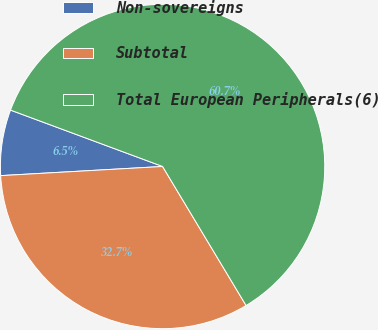Convert chart. <chart><loc_0><loc_0><loc_500><loc_500><pie_chart><fcel>Non-sovereigns<fcel>Subtotal<fcel>Total European Peripherals(6)<nl><fcel>6.55%<fcel>32.71%<fcel>60.74%<nl></chart> 